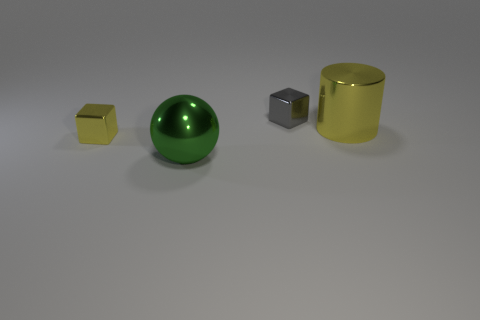Add 4 yellow cylinders. How many objects exist? 8 Subtract all cylinders. How many objects are left? 3 Subtract all small purple metal spheres. Subtract all tiny gray things. How many objects are left? 3 Add 3 yellow cylinders. How many yellow cylinders are left? 4 Add 2 large cyan rubber spheres. How many large cyan rubber spheres exist? 2 Subtract 0 purple cylinders. How many objects are left? 4 Subtract all purple blocks. Subtract all yellow balls. How many blocks are left? 2 